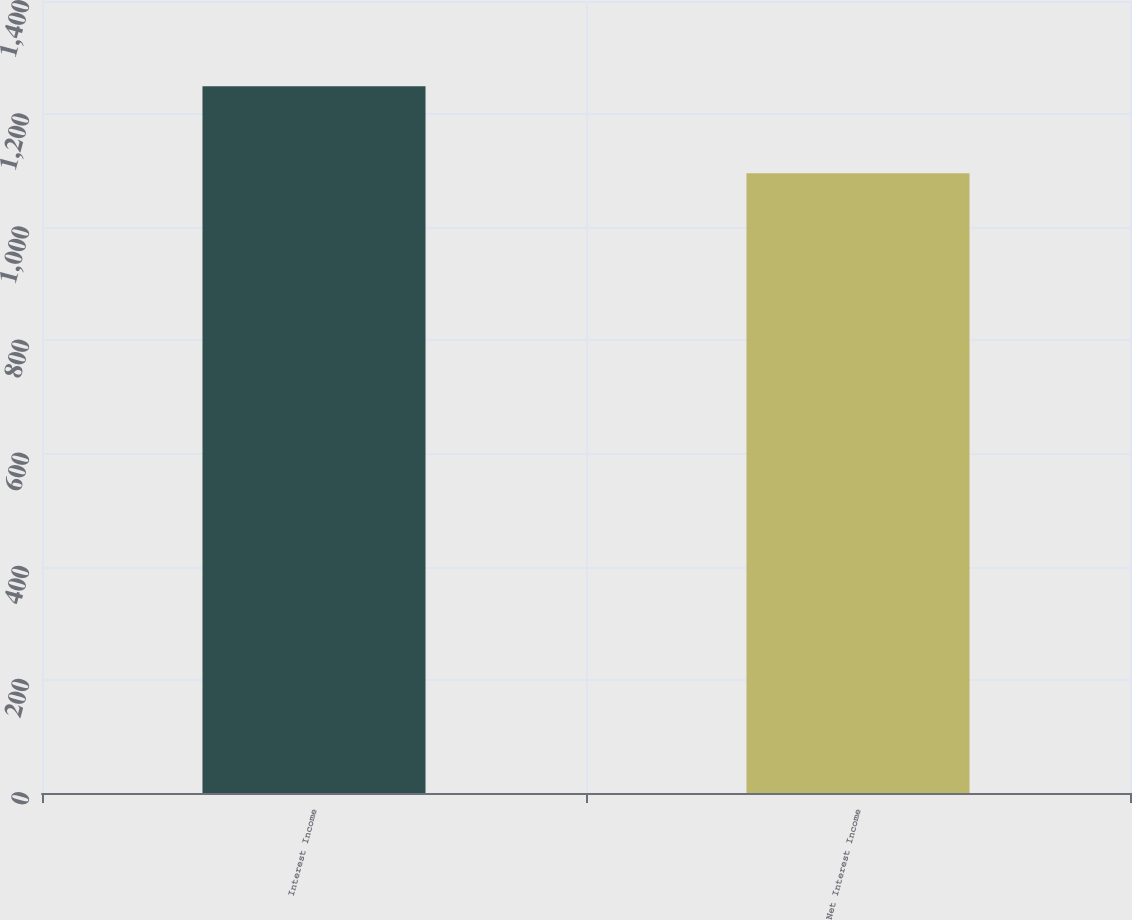Convert chart to OTSL. <chart><loc_0><loc_0><loc_500><loc_500><bar_chart><fcel>Interest Income<fcel>Net Interest Income<nl><fcel>1249.3<fcel>1095.4<nl></chart> 